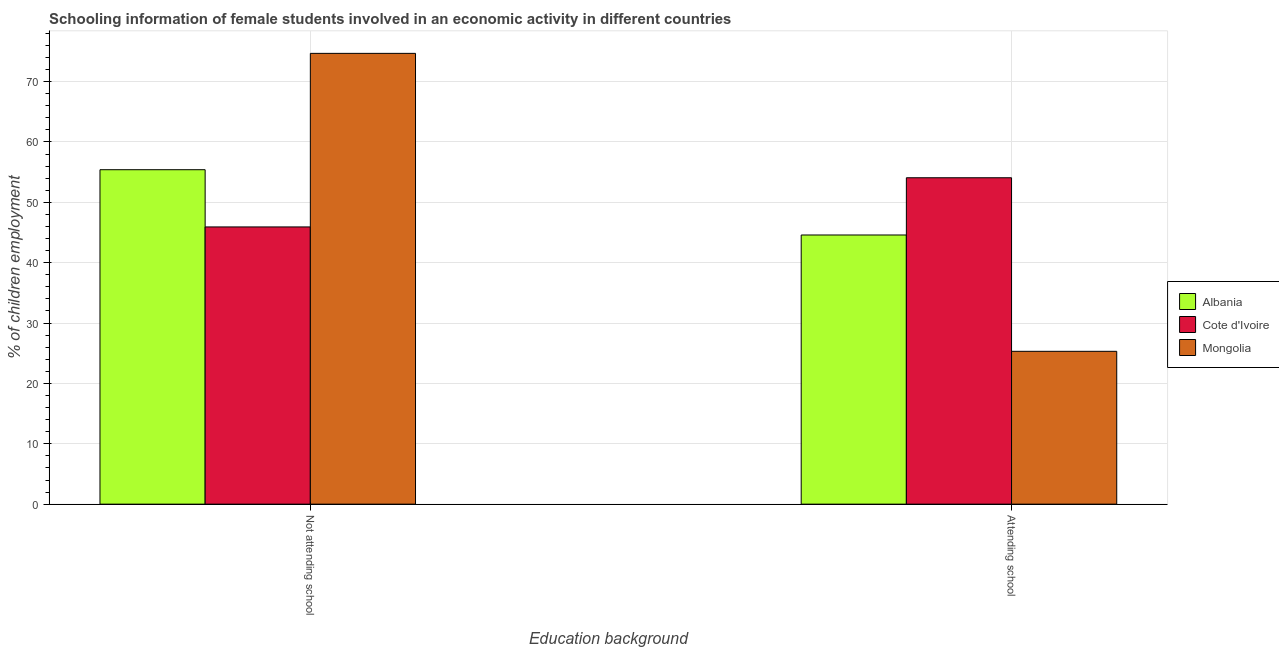How many different coloured bars are there?
Offer a very short reply. 3. Are the number of bars per tick equal to the number of legend labels?
Give a very brief answer. Yes. Are the number of bars on each tick of the X-axis equal?
Your answer should be very brief. Yes. How many bars are there on the 2nd tick from the left?
Your response must be concise. 3. How many bars are there on the 1st tick from the right?
Provide a succinct answer. 3. What is the label of the 1st group of bars from the left?
Offer a very short reply. Not attending school. What is the percentage of employed females who are not attending school in Albania?
Make the answer very short. 55.41. Across all countries, what is the maximum percentage of employed females who are attending school?
Offer a very short reply. 54.07. Across all countries, what is the minimum percentage of employed females who are attending school?
Offer a terse response. 25.32. In which country was the percentage of employed females who are not attending school maximum?
Offer a very short reply. Mongolia. In which country was the percentage of employed females who are not attending school minimum?
Your response must be concise. Cote d'Ivoire. What is the total percentage of employed females who are attending school in the graph?
Your response must be concise. 123.99. What is the difference between the percentage of employed females who are attending school in Albania and that in Cote d'Ivoire?
Offer a terse response. -9.48. What is the difference between the percentage of employed females who are not attending school in Mongolia and the percentage of employed females who are attending school in Albania?
Provide a succinct answer. 30.09. What is the average percentage of employed females who are not attending school per country?
Make the answer very short. 58.67. What is the difference between the percentage of employed females who are not attending school and percentage of employed females who are attending school in Albania?
Offer a terse response. 10.82. In how many countries, is the percentage of employed females who are attending school greater than 4 %?
Ensure brevity in your answer.  3. What is the ratio of the percentage of employed females who are not attending school in Cote d'Ivoire to that in Albania?
Your answer should be very brief. 0.83. Is the percentage of employed females who are not attending school in Mongolia less than that in Albania?
Ensure brevity in your answer.  No. In how many countries, is the percentage of employed females who are not attending school greater than the average percentage of employed females who are not attending school taken over all countries?
Your response must be concise. 1. What does the 3rd bar from the left in Attending school represents?
Your answer should be very brief. Mongolia. What does the 3rd bar from the right in Attending school represents?
Your answer should be very brief. Albania. Are all the bars in the graph horizontal?
Your answer should be very brief. No. How many countries are there in the graph?
Your answer should be very brief. 3. Does the graph contain any zero values?
Provide a succinct answer. No. Does the graph contain grids?
Your response must be concise. Yes. How are the legend labels stacked?
Provide a succinct answer. Vertical. What is the title of the graph?
Make the answer very short. Schooling information of female students involved in an economic activity in different countries. What is the label or title of the X-axis?
Offer a terse response. Education background. What is the label or title of the Y-axis?
Offer a very short reply. % of children employment. What is the % of children employment in Albania in Not attending school?
Your response must be concise. 55.41. What is the % of children employment of Cote d'Ivoire in Not attending school?
Provide a short and direct response. 45.93. What is the % of children employment in Mongolia in Not attending school?
Ensure brevity in your answer.  74.68. What is the % of children employment in Albania in Attending school?
Ensure brevity in your answer.  44.59. What is the % of children employment of Cote d'Ivoire in Attending school?
Provide a succinct answer. 54.07. What is the % of children employment of Mongolia in Attending school?
Offer a terse response. 25.32. Across all Education background, what is the maximum % of children employment of Albania?
Ensure brevity in your answer.  55.41. Across all Education background, what is the maximum % of children employment of Cote d'Ivoire?
Ensure brevity in your answer.  54.07. Across all Education background, what is the maximum % of children employment in Mongolia?
Provide a short and direct response. 74.68. Across all Education background, what is the minimum % of children employment in Albania?
Keep it short and to the point. 44.59. Across all Education background, what is the minimum % of children employment in Cote d'Ivoire?
Make the answer very short. 45.93. Across all Education background, what is the minimum % of children employment of Mongolia?
Offer a terse response. 25.32. What is the difference between the % of children employment of Albania in Not attending school and that in Attending school?
Give a very brief answer. 10.81. What is the difference between the % of children employment of Cote d'Ivoire in Not attending school and that in Attending school?
Offer a very short reply. -8.15. What is the difference between the % of children employment in Mongolia in Not attending school and that in Attending school?
Your response must be concise. 49.36. What is the difference between the % of children employment of Albania in Not attending school and the % of children employment of Cote d'Ivoire in Attending school?
Provide a short and direct response. 1.33. What is the difference between the % of children employment in Albania in Not attending school and the % of children employment in Mongolia in Attending school?
Your answer should be very brief. 30.09. What is the difference between the % of children employment in Cote d'Ivoire in Not attending school and the % of children employment in Mongolia in Attending school?
Offer a terse response. 20.61. What is the average % of children employment in Cote d'Ivoire per Education background?
Provide a short and direct response. 50. What is the difference between the % of children employment in Albania and % of children employment in Cote d'Ivoire in Not attending school?
Keep it short and to the point. 9.48. What is the difference between the % of children employment in Albania and % of children employment in Mongolia in Not attending school?
Provide a short and direct response. -19.27. What is the difference between the % of children employment of Cote d'Ivoire and % of children employment of Mongolia in Not attending school?
Keep it short and to the point. -28.76. What is the difference between the % of children employment of Albania and % of children employment of Cote d'Ivoire in Attending school?
Give a very brief answer. -9.48. What is the difference between the % of children employment in Albania and % of children employment in Mongolia in Attending school?
Make the answer very short. 19.27. What is the difference between the % of children employment in Cote d'Ivoire and % of children employment in Mongolia in Attending school?
Provide a succinct answer. 28.76. What is the ratio of the % of children employment of Albania in Not attending school to that in Attending school?
Offer a terse response. 1.24. What is the ratio of the % of children employment in Cote d'Ivoire in Not attending school to that in Attending school?
Offer a very short reply. 0.85. What is the ratio of the % of children employment of Mongolia in Not attending school to that in Attending school?
Ensure brevity in your answer.  2.95. What is the difference between the highest and the second highest % of children employment of Albania?
Offer a very short reply. 10.81. What is the difference between the highest and the second highest % of children employment of Cote d'Ivoire?
Provide a succinct answer. 8.15. What is the difference between the highest and the second highest % of children employment in Mongolia?
Offer a very short reply. 49.36. What is the difference between the highest and the lowest % of children employment in Albania?
Provide a short and direct response. 10.81. What is the difference between the highest and the lowest % of children employment in Cote d'Ivoire?
Your answer should be very brief. 8.15. What is the difference between the highest and the lowest % of children employment in Mongolia?
Your answer should be very brief. 49.36. 